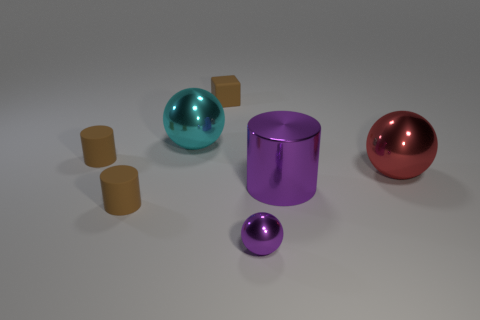Add 1 small rubber objects. How many objects exist? 8 Subtract all spheres. How many objects are left? 4 Add 4 tiny brown cubes. How many tiny brown cubes exist? 5 Subtract 0 green cylinders. How many objects are left? 7 Subtract all tiny red matte spheres. Subtract all big red balls. How many objects are left? 6 Add 1 brown cylinders. How many brown cylinders are left? 3 